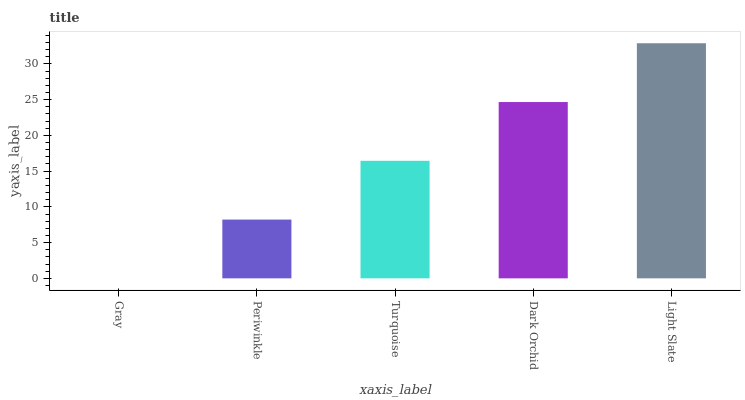Is Periwinkle the minimum?
Answer yes or no. No. Is Periwinkle the maximum?
Answer yes or no. No. Is Periwinkle greater than Gray?
Answer yes or no. Yes. Is Gray less than Periwinkle?
Answer yes or no. Yes. Is Gray greater than Periwinkle?
Answer yes or no. No. Is Periwinkle less than Gray?
Answer yes or no. No. Is Turquoise the high median?
Answer yes or no. Yes. Is Turquoise the low median?
Answer yes or no. Yes. Is Periwinkle the high median?
Answer yes or no. No. Is Dark Orchid the low median?
Answer yes or no. No. 